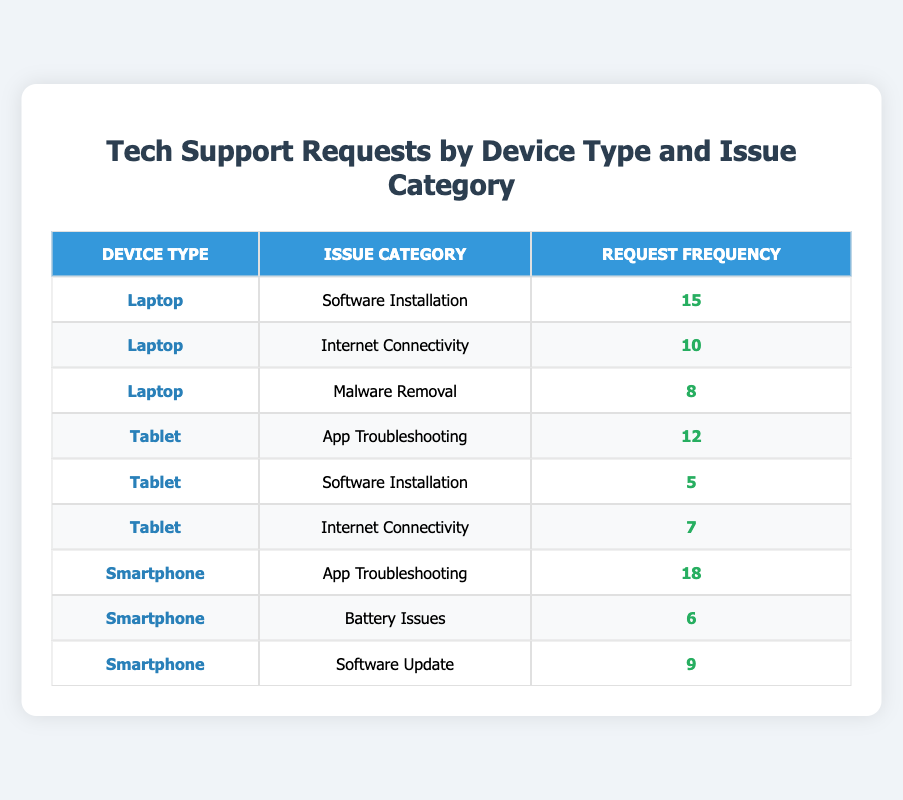What is the most common issue category for Smartphones? Looking at the table, the issue with the highest request frequency for Smartphones is "App Troubleshooting" with a frequency of 18.
Answer: App Troubleshooting How many tech support requests were made for Tablets regarding Internet Connectivity? From the table, it shows that there were 7 requests specifically for Internet Connectivity under the Tablet device type.
Answer: 7 What is the total frequency of requests for all device types combined? To find the total, I'll sum the request frequencies: 15 (Laptop - Software Installation) + 10 (Laptop - Internet Connectivity) + 8 (Laptop - Malware Removal) + 12 (Tablet - App Troubleshooting) + 5 (Tablet - Software Installation) + 7 (Tablet - Internet Connectivity) + 18 (Smartphone - App Troubleshooting) + 6 (Smartphone - Battery Issues) + 9 (Smartphone - Software Update) = 90.
Answer: 90 Are Battery Issues more frequently reported than Malware Removal? Referring to the table, "Battery Issues" has a frequency of 6, whereas "Malware Removal" has a frequency of 8. Since 6 is not greater than 8, the answer is no.
Answer: No What is the average frequency of tech support requests for Laptops? First, I will list the request frequencies for Laptops: 15 (Software Installation), 10 (Internet Connectivity), and 8 (Malware Removal). I'll sum these values: 15 + 10 + 8 = 33. There are 3 request categories, so the average would be 33 / 3 = 11.
Answer: 11 Which device type has the least number of total tech support requests? I will calculate the sum of request frequencies for each device type. For Laptops: 15 + 10 + 8 = 33, for Tablets: 12 + 5 + 7 = 24, and for Smartphones: 18 + 6 + 9 = 33. The least sum is for Tablets, with a total of 24.
Answer: Tablet How many requests were made for Software Installation across all device types? In the table, I see that there are 15 requests for Software Installation on Laptops and 5 on Tablets. Adding these gives a total of 15 + 5 = 20 requests for Software Installation across all devices.
Answer: 20 Which issue category has the highest request frequency overall? By examining the table, "App Troubleshooting" has 18 requests, while no other category exceeds this. Therefore, it has the highest frequency.
Answer: App Troubleshooting Did the frequency of App Troubleshooting requests for Smartphones exceed the total frequency of Software Installation requests for both Laptops and Tablets? The frequency for "App Troubleshooting" on Smartphones is 18, and for "Software Installation" on Laptops is 15 and on Tablets is 5, summing them gives 15 + 5 = 20. Since 18 is not greater than 20, the answer is no.
Answer: No 